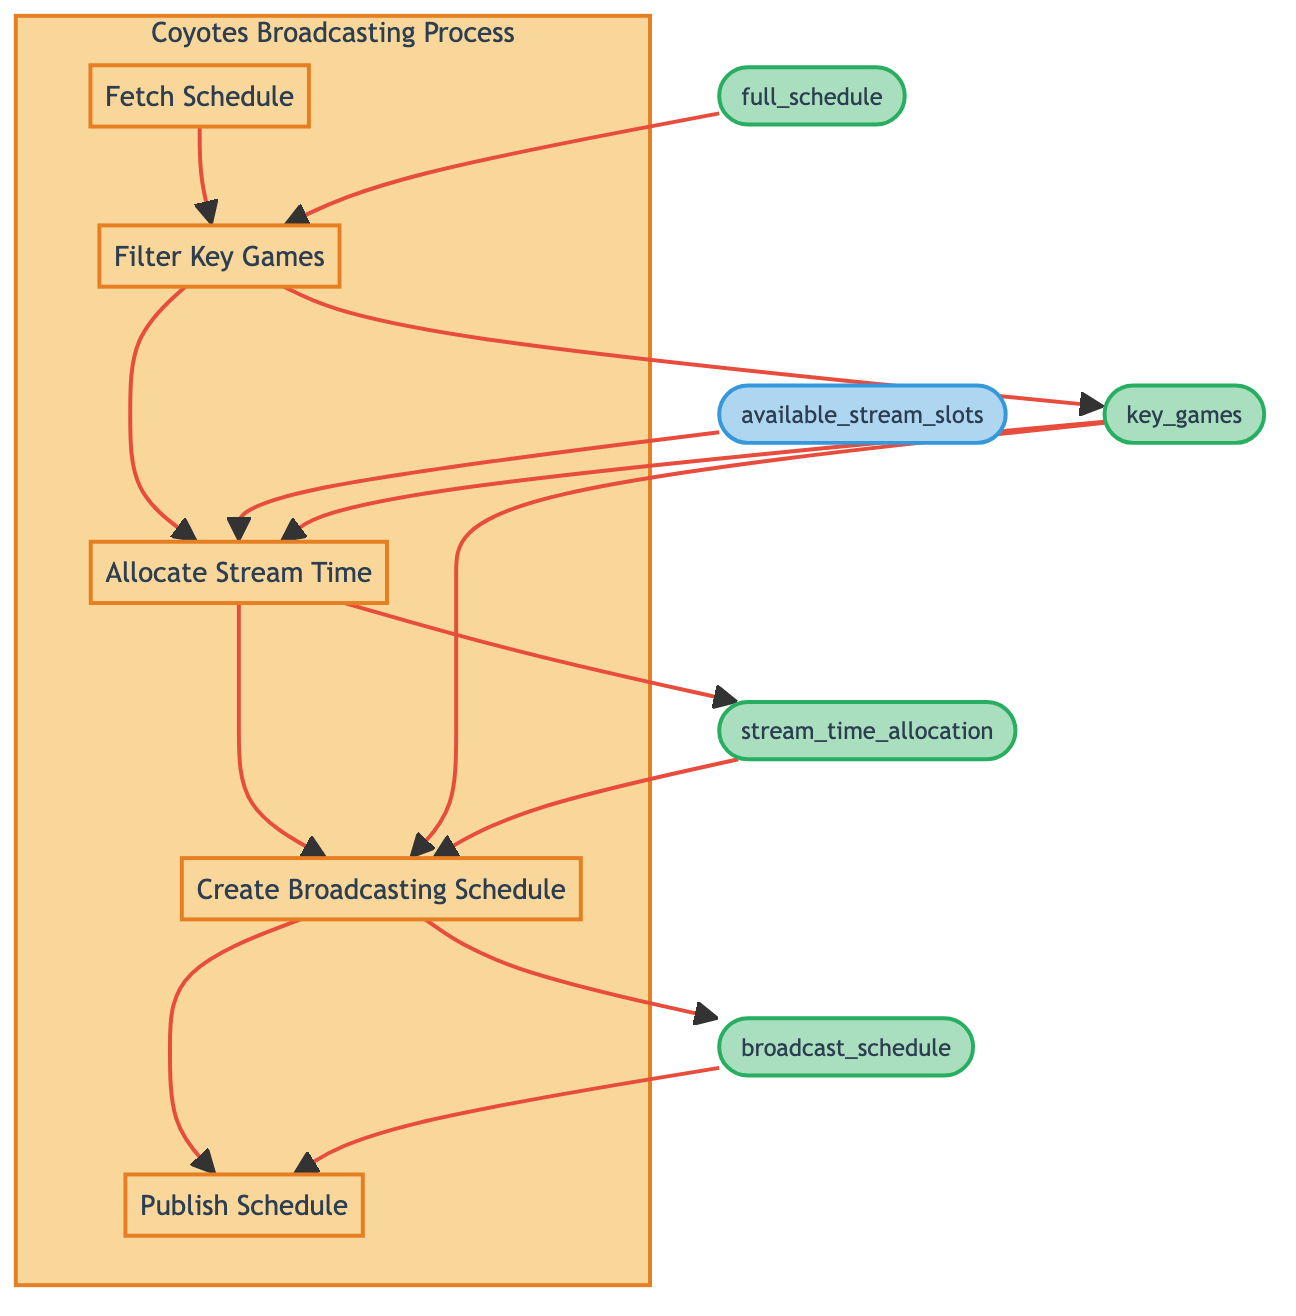What is the first step in the process? The process starts with the node "Fetch Schedule," which is positioned at the bottom of the diagram as the initial step. It indicates the first action taken in the flow.
Answer: Fetch Schedule How many steps are in the Coyotes' broadcasting process? There are five distinct steps in the flowchart that represent the entire broadcasting process from fetching the schedule to publishing it.
Answer: Five What is the output of the 'Allocate Stream Time' step? The output from the 'Allocate Stream Time' step is identified as "stream_time_allocation," which is produced after the allocation of appropriate stream times for key games.
Answer: stream_time_allocation Which step comes directly after 'Filter Key Games'? The next step that follows 'Filter Key Games' is 'Allocate Stream Time,' indicating that after filtering the key games, the process moves on to allocating stream times.
Answer: Allocate Stream Time What type of input does 'Create Broadcasting Schedule' require? 'Create Broadcasting Schedule' requires two inputs: 'key_games' and 'stream_time_allocation,' which are essential for generating the broadcasting schedule.
Answer: key_games, stream_time_allocation What is the final output of the process? The conclusion of the flow is the 'Publish Schedule' which outputs the final broadcasting schedule available for Coyotes' fans on their website and social media.
Answer: broadcast_schedule How does the 'Fetch Schedule' contribute to the subsequent steps? The 'Fetch Schedule' step is critical as it provides the necessary 'full_schedule' as output, which is required as input for the next step, 'Filter Key Games.'
Answer: full_schedule How many outputs are generated in the total process? A total of four outputs are produced in the steps: 'full_schedule,' 'key_games,' 'stream_time_allocation,' and 'broadcast_schedule.'
Answer: Four What step involves deciding on time slots for games? The step responsible for deciding on time slots for the games is 'Allocate Stream Time,' where appropriate stream times are allocated for the key games considering various factors.
Answer: Allocate Stream Time 